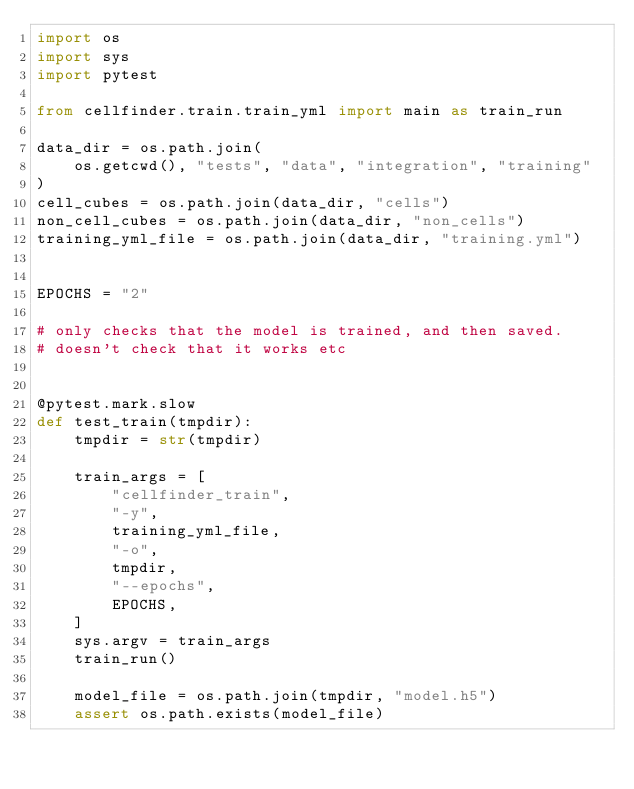Convert code to text. <code><loc_0><loc_0><loc_500><loc_500><_Python_>import os
import sys
import pytest

from cellfinder.train.train_yml import main as train_run

data_dir = os.path.join(
    os.getcwd(), "tests", "data", "integration", "training"
)
cell_cubes = os.path.join(data_dir, "cells")
non_cell_cubes = os.path.join(data_dir, "non_cells")
training_yml_file = os.path.join(data_dir, "training.yml")


EPOCHS = "2"

# only checks that the model is trained, and then saved.
# doesn't check that it works etc


@pytest.mark.slow
def test_train(tmpdir):
    tmpdir = str(tmpdir)

    train_args = [
        "cellfinder_train",
        "-y",
        training_yml_file,
        "-o",
        tmpdir,
        "--epochs",
        EPOCHS,
    ]
    sys.argv = train_args
    train_run()

    model_file = os.path.join(tmpdir, "model.h5")
    assert os.path.exists(model_file)
</code> 